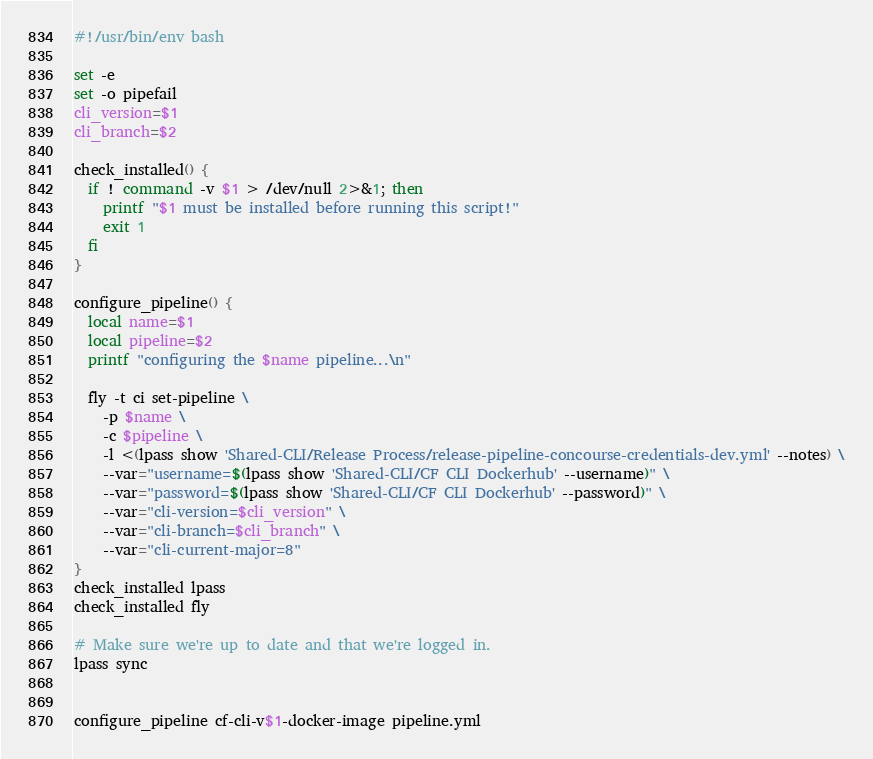<code> <loc_0><loc_0><loc_500><loc_500><_Bash_>#!/usr/bin/env bash

set -e
set -o pipefail
cli_version=$1
cli_branch=$2

check_installed() {
  if ! command -v $1 > /dev/null 2>&1; then
    printf "$1 must be installed before running this script!"
    exit 1
  fi
}

configure_pipeline() {
  local name=$1
  local pipeline=$2
  printf "configuring the $name pipeline...\n"

  fly -t ci set-pipeline \
    -p $name \
    -c $pipeline \
    -l <(lpass show 'Shared-CLI/Release Process/release-pipeline-concourse-credentials-dev.yml' --notes) \
    --var="username=$(lpass show 'Shared-CLI/CF CLI Dockerhub' --username)" \
    --var="password=$(lpass show 'Shared-CLI/CF CLI Dockerhub' --password)" \
    --var="cli-version=$cli_version" \
    --var="cli-branch=$cli_branch" \
    --var="cli-current-major=8"
}
check_installed lpass
check_installed fly

# Make sure we're up to date and that we're logged in.
lpass sync


configure_pipeline cf-cli-v$1-docker-image pipeline.yml
</code> 